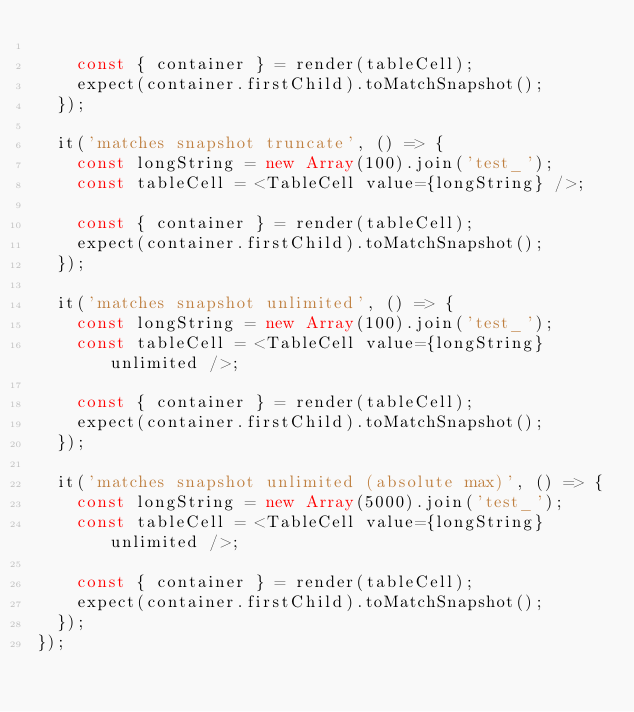<code> <loc_0><loc_0><loc_500><loc_500><_TypeScript_>
    const { container } = render(tableCell);
    expect(container.firstChild).toMatchSnapshot();
  });

  it('matches snapshot truncate', () => {
    const longString = new Array(100).join('test_');
    const tableCell = <TableCell value={longString} />;

    const { container } = render(tableCell);
    expect(container.firstChild).toMatchSnapshot();
  });

  it('matches snapshot unlimited', () => {
    const longString = new Array(100).join('test_');
    const tableCell = <TableCell value={longString} unlimited />;

    const { container } = render(tableCell);
    expect(container.firstChild).toMatchSnapshot();
  });

  it('matches snapshot unlimited (absolute max)', () => {
    const longString = new Array(5000).join('test_');
    const tableCell = <TableCell value={longString} unlimited />;

    const { container } = render(tableCell);
    expect(container.firstChild).toMatchSnapshot();
  });
});
</code> 